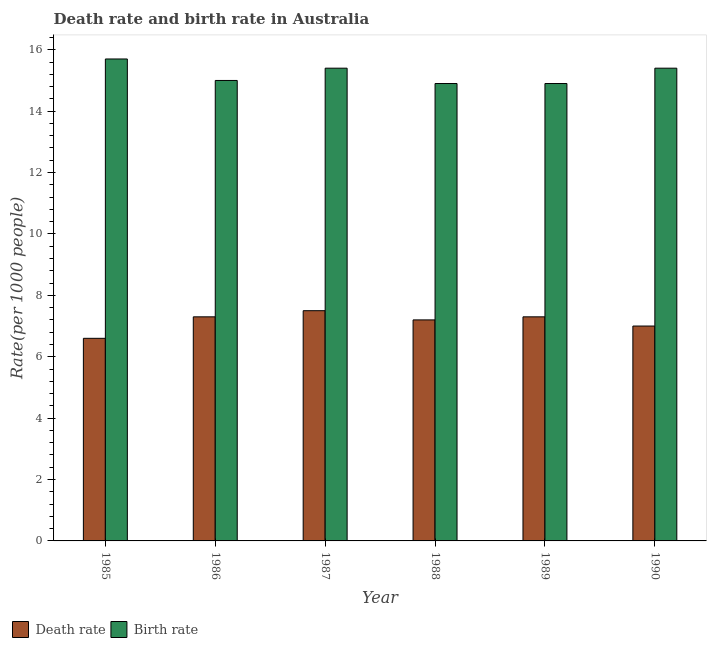How many different coloured bars are there?
Offer a very short reply. 2. How many groups of bars are there?
Offer a very short reply. 6. What is the label of the 4th group of bars from the left?
Your answer should be compact. 1988. What is the death rate in 1990?
Offer a very short reply. 7. Across all years, what is the maximum birth rate?
Offer a terse response. 15.7. In which year was the death rate minimum?
Your answer should be compact. 1985. What is the total death rate in the graph?
Provide a short and direct response. 42.9. What is the difference between the birth rate in 1985 and that in 1988?
Make the answer very short. 0.8. What is the difference between the death rate in 1990 and the birth rate in 1987?
Give a very brief answer. -0.5. What is the average birth rate per year?
Provide a succinct answer. 15.22. In the year 1990, what is the difference between the birth rate and death rate?
Offer a terse response. 0. What is the ratio of the birth rate in 1987 to that in 1988?
Ensure brevity in your answer.  1.03. Is the birth rate in 1985 less than that in 1988?
Offer a very short reply. No. What is the difference between the highest and the second highest birth rate?
Provide a succinct answer. 0.3. What is the difference between the highest and the lowest birth rate?
Your response must be concise. 0.8. In how many years, is the death rate greater than the average death rate taken over all years?
Offer a very short reply. 4. What does the 2nd bar from the left in 1987 represents?
Offer a terse response. Birth rate. What does the 2nd bar from the right in 1988 represents?
Your answer should be very brief. Death rate. How many bars are there?
Provide a short and direct response. 12. How many years are there in the graph?
Keep it short and to the point. 6. Are the values on the major ticks of Y-axis written in scientific E-notation?
Keep it short and to the point. No. Does the graph contain any zero values?
Offer a very short reply. No. Where does the legend appear in the graph?
Provide a short and direct response. Bottom left. How many legend labels are there?
Your response must be concise. 2. How are the legend labels stacked?
Your response must be concise. Horizontal. What is the title of the graph?
Give a very brief answer. Death rate and birth rate in Australia. Does "Birth rate" appear as one of the legend labels in the graph?
Provide a succinct answer. Yes. What is the label or title of the Y-axis?
Make the answer very short. Rate(per 1000 people). What is the Rate(per 1000 people) in Death rate in 1987?
Your answer should be very brief. 7.5. What is the Rate(per 1000 people) in Birth rate in 1987?
Provide a short and direct response. 15.4. What is the Rate(per 1000 people) of Death rate in 1988?
Make the answer very short. 7.2. What is the Rate(per 1000 people) in Birth rate in 1988?
Make the answer very short. 14.9. What is the Rate(per 1000 people) in Death rate in 1989?
Provide a short and direct response. 7.3. What is the Rate(per 1000 people) in Death rate in 1990?
Provide a succinct answer. 7. Across all years, what is the maximum Rate(per 1000 people) in Death rate?
Keep it short and to the point. 7.5. Across all years, what is the maximum Rate(per 1000 people) of Birth rate?
Make the answer very short. 15.7. Across all years, what is the minimum Rate(per 1000 people) of Death rate?
Your answer should be very brief. 6.6. What is the total Rate(per 1000 people) of Death rate in the graph?
Keep it short and to the point. 42.9. What is the total Rate(per 1000 people) in Birth rate in the graph?
Your answer should be very brief. 91.3. What is the difference between the Rate(per 1000 people) of Death rate in 1985 and that in 1988?
Give a very brief answer. -0.6. What is the difference between the Rate(per 1000 people) of Death rate in 1986 and that in 1987?
Offer a terse response. -0.2. What is the difference between the Rate(per 1000 people) in Death rate in 1986 and that in 1988?
Make the answer very short. 0.1. What is the difference between the Rate(per 1000 people) of Death rate in 1986 and that in 1989?
Offer a very short reply. 0. What is the difference between the Rate(per 1000 people) in Death rate in 1987 and that in 1988?
Give a very brief answer. 0.3. What is the difference between the Rate(per 1000 people) in Birth rate in 1987 and that in 1988?
Provide a succinct answer. 0.5. What is the difference between the Rate(per 1000 people) in Birth rate in 1987 and that in 1989?
Ensure brevity in your answer.  0.5. What is the difference between the Rate(per 1000 people) in Birth rate in 1987 and that in 1990?
Offer a very short reply. 0. What is the difference between the Rate(per 1000 people) in Birth rate in 1988 and that in 1989?
Give a very brief answer. 0. What is the difference between the Rate(per 1000 people) in Birth rate in 1988 and that in 1990?
Give a very brief answer. -0.5. What is the difference between the Rate(per 1000 people) in Death rate in 1989 and that in 1990?
Keep it short and to the point. 0.3. What is the difference between the Rate(per 1000 people) in Birth rate in 1989 and that in 1990?
Provide a short and direct response. -0.5. What is the difference between the Rate(per 1000 people) of Death rate in 1985 and the Rate(per 1000 people) of Birth rate in 1987?
Your answer should be compact. -8.8. What is the difference between the Rate(per 1000 people) in Death rate in 1985 and the Rate(per 1000 people) in Birth rate in 1988?
Your response must be concise. -8.3. What is the difference between the Rate(per 1000 people) of Death rate in 1986 and the Rate(per 1000 people) of Birth rate in 1989?
Give a very brief answer. -7.6. What is the difference between the Rate(per 1000 people) in Death rate in 1986 and the Rate(per 1000 people) in Birth rate in 1990?
Ensure brevity in your answer.  -8.1. What is the difference between the Rate(per 1000 people) of Death rate in 1987 and the Rate(per 1000 people) of Birth rate in 1988?
Offer a very short reply. -7.4. What is the difference between the Rate(per 1000 people) of Death rate in 1988 and the Rate(per 1000 people) of Birth rate in 1989?
Make the answer very short. -7.7. What is the difference between the Rate(per 1000 people) in Death rate in 1988 and the Rate(per 1000 people) in Birth rate in 1990?
Ensure brevity in your answer.  -8.2. What is the difference between the Rate(per 1000 people) in Death rate in 1989 and the Rate(per 1000 people) in Birth rate in 1990?
Your answer should be very brief. -8.1. What is the average Rate(per 1000 people) of Death rate per year?
Offer a very short reply. 7.15. What is the average Rate(per 1000 people) in Birth rate per year?
Your answer should be compact. 15.22. In the year 1986, what is the difference between the Rate(per 1000 people) of Death rate and Rate(per 1000 people) of Birth rate?
Offer a terse response. -7.7. In the year 1988, what is the difference between the Rate(per 1000 people) of Death rate and Rate(per 1000 people) of Birth rate?
Provide a succinct answer. -7.7. What is the ratio of the Rate(per 1000 people) of Death rate in 1985 to that in 1986?
Give a very brief answer. 0.9. What is the ratio of the Rate(per 1000 people) of Birth rate in 1985 to that in 1986?
Keep it short and to the point. 1.05. What is the ratio of the Rate(per 1000 people) of Death rate in 1985 to that in 1987?
Give a very brief answer. 0.88. What is the ratio of the Rate(per 1000 people) of Birth rate in 1985 to that in 1987?
Offer a terse response. 1.02. What is the ratio of the Rate(per 1000 people) in Death rate in 1985 to that in 1988?
Your answer should be very brief. 0.92. What is the ratio of the Rate(per 1000 people) in Birth rate in 1985 to that in 1988?
Keep it short and to the point. 1.05. What is the ratio of the Rate(per 1000 people) in Death rate in 1985 to that in 1989?
Ensure brevity in your answer.  0.9. What is the ratio of the Rate(per 1000 people) in Birth rate in 1985 to that in 1989?
Make the answer very short. 1.05. What is the ratio of the Rate(per 1000 people) of Death rate in 1985 to that in 1990?
Give a very brief answer. 0.94. What is the ratio of the Rate(per 1000 people) in Birth rate in 1985 to that in 1990?
Your answer should be very brief. 1.02. What is the ratio of the Rate(per 1000 people) in Death rate in 1986 to that in 1987?
Provide a succinct answer. 0.97. What is the ratio of the Rate(per 1000 people) in Birth rate in 1986 to that in 1987?
Offer a terse response. 0.97. What is the ratio of the Rate(per 1000 people) of Death rate in 1986 to that in 1988?
Keep it short and to the point. 1.01. What is the ratio of the Rate(per 1000 people) in Birth rate in 1986 to that in 1988?
Offer a terse response. 1.01. What is the ratio of the Rate(per 1000 people) in Death rate in 1986 to that in 1990?
Give a very brief answer. 1.04. What is the ratio of the Rate(per 1000 people) of Birth rate in 1986 to that in 1990?
Make the answer very short. 0.97. What is the ratio of the Rate(per 1000 people) of Death rate in 1987 to that in 1988?
Your answer should be compact. 1.04. What is the ratio of the Rate(per 1000 people) of Birth rate in 1987 to that in 1988?
Your response must be concise. 1.03. What is the ratio of the Rate(per 1000 people) in Death rate in 1987 to that in 1989?
Make the answer very short. 1.03. What is the ratio of the Rate(per 1000 people) in Birth rate in 1987 to that in 1989?
Give a very brief answer. 1.03. What is the ratio of the Rate(per 1000 people) in Death rate in 1987 to that in 1990?
Your answer should be very brief. 1.07. What is the ratio of the Rate(per 1000 people) in Birth rate in 1987 to that in 1990?
Your answer should be very brief. 1. What is the ratio of the Rate(per 1000 people) in Death rate in 1988 to that in 1989?
Keep it short and to the point. 0.99. What is the ratio of the Rate(per 1000 people) in Death rate in 1988 to that in 1990?
Provide a succinct answer. 1.03. What is the ratio of the Rate(per 1000 people) of Birth rate in 1988 to that in 1990?
Your answer should be compact. 0.97. What is the ratio of the Rate(per 1000 people) of Death rate in 1989 to that in 1990?
Your answer should be compact. 1.04. What is the ratio of the Rate(per 1000 people) in Birth rate in 1989 to that in 1990?
Provide a succinct answer. 0.97. 